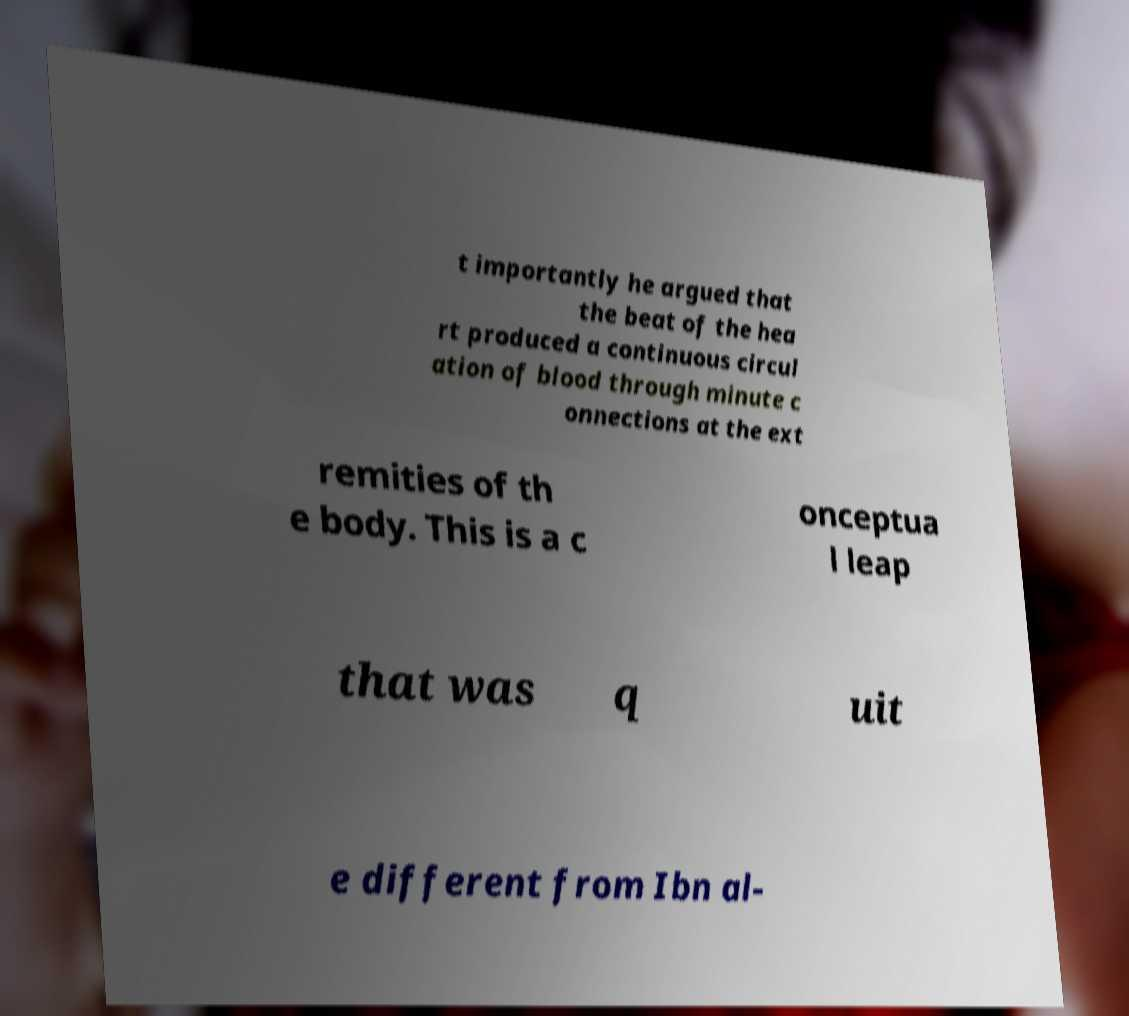Please read and relay the text visible in this image. What does it say? t importantly he argued that the beat of the hea rt produced a continuous circul ation of blood through minute c onnections at the ext remities of th e body. This is a c onceptua l leap that was q uit e different from Ibn al- 